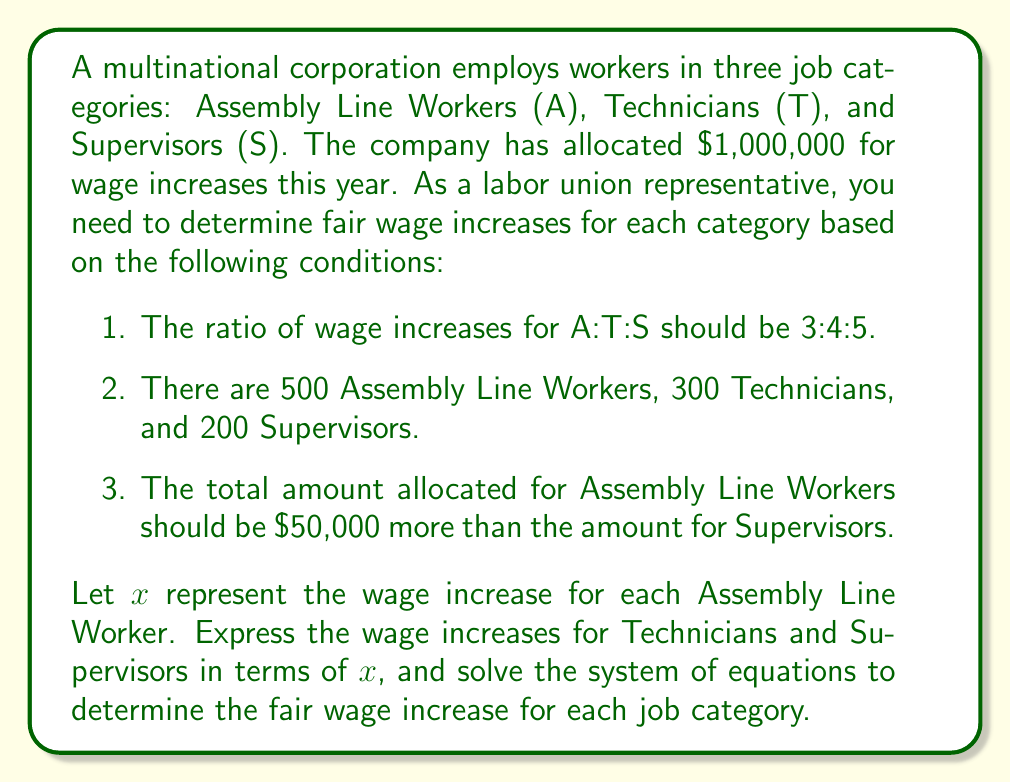Can you solve this math problem? Let's approach this step-by-step:

1) First, let's define our variables:
   $x$ = wage increase for each Assembly Line Worker
   $\frac{4}{3}x$ = wage increase for each Technician (based on the 3:4:5 ratio)
   $\frac{5}{3}x$ = wage increase for each Supervisor (based on the 3:4:5 ratio)

2) Now, we can set up our first equation based on the total allocation:
   $500x + 300(\frac{4}{3}x) + 200(\frac{5}{3}x) = 1,000,000$

3) Simplify this equation:
   $500x + 400x + \frac{1000}{3}x = 1,000,000$
   $1500x + \frac{1000}{3}x = 1,000,000$
   $4500x + 1000x = 3,000,000$
   $5500x = 3,000,000$

4) Now, let's set up our second equation based on the condition that the total for Assembly Line Workers should be $50,000 more than for Supervisors:
   $500x = 200(\frac{5}{3}x) + 50,000$

5) Simplify this equation:
   $500x = \frac{1000}{3}x + 50,000$
   $1500x = 1000x + 150,000$
   $500x = 150,000$
   $x = 300$

6) Now that we know $x$, we can calculate the wage increases for each category:
   Assembly Line Workers: $x = 300$
   Technicians: $\frac{4}{3}x = \frac{4}{3}(300) = 400$
   Supervisors: $\frac{5}{3}x = \frac{5}{3}(300) = 500$

7) Let's verify our solution:
   Total allocation: $500(300) + 300(400) + 200(500) = 150,000 + 120,000 + 100,000 = 370,000$
   Difference between Assembly Line Workers and Supervisors: $150,000 - 100,000 = 50,000$

Our solution satisfies all conditions.
Answer: Assembly Line Workers: $300, Technicians: $400, Supervisors: $500 